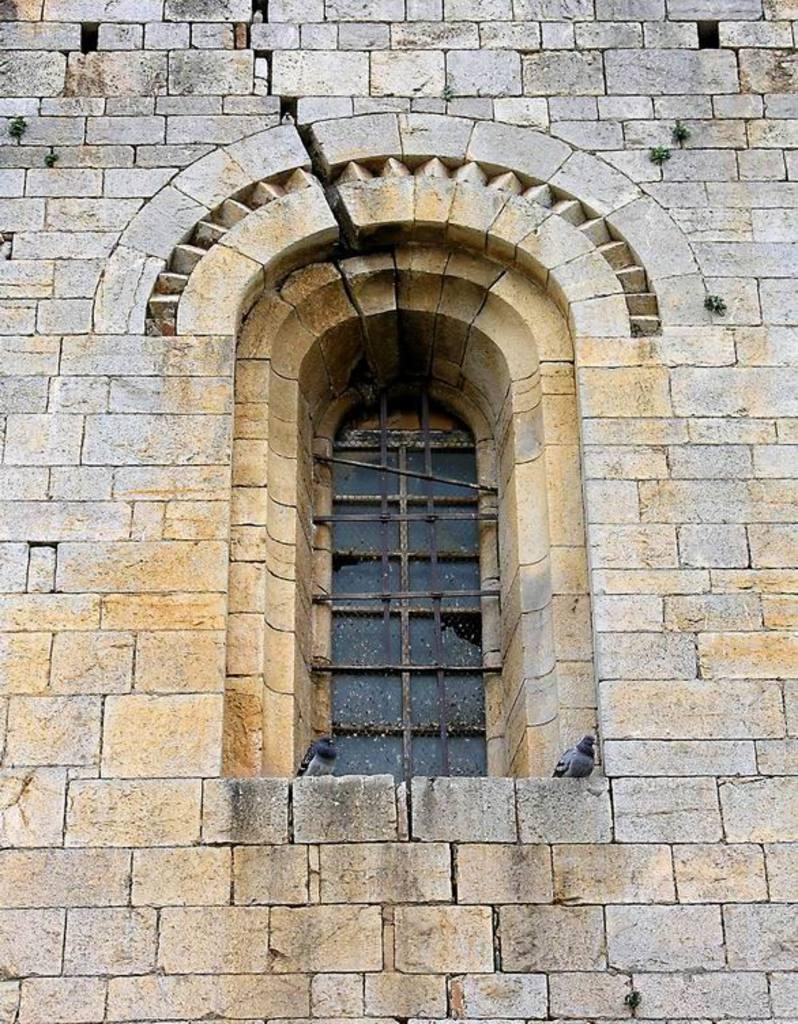What type of structure can be seen in the image? There is a wall in the image. Is there any opening in the wall? Yes, there is a window in the image. What can be seen through the window? Birds are visible in the image. What type of lamp is being used by the farmer in the image? There is no lamp or farmer present in the image; it only features a wall, a window, and birds. 